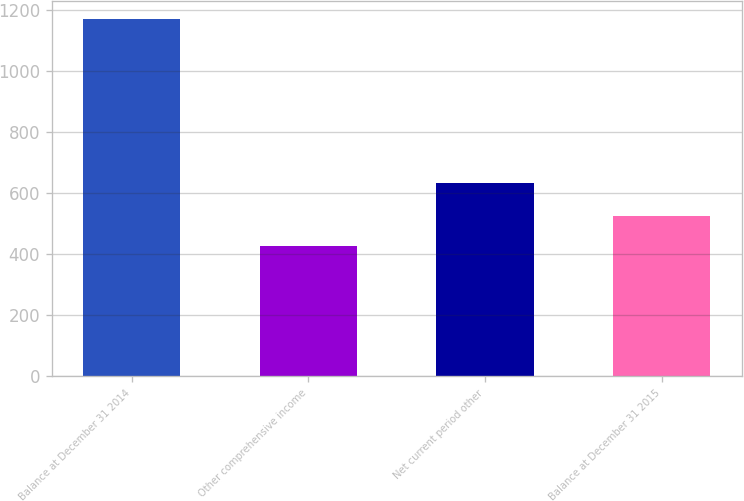Convert chart. <chart><loc_0><loc_0><loc_500><loc_500><bar_chart><fcel>Balance at December 31 2014<fcel>Other comprehensive income<fcel>Net current period other<fcel>Balance at December 31 2015<nl><fcel>1171<fcel>428<fcel>633<fcel>526<nl></chart> 